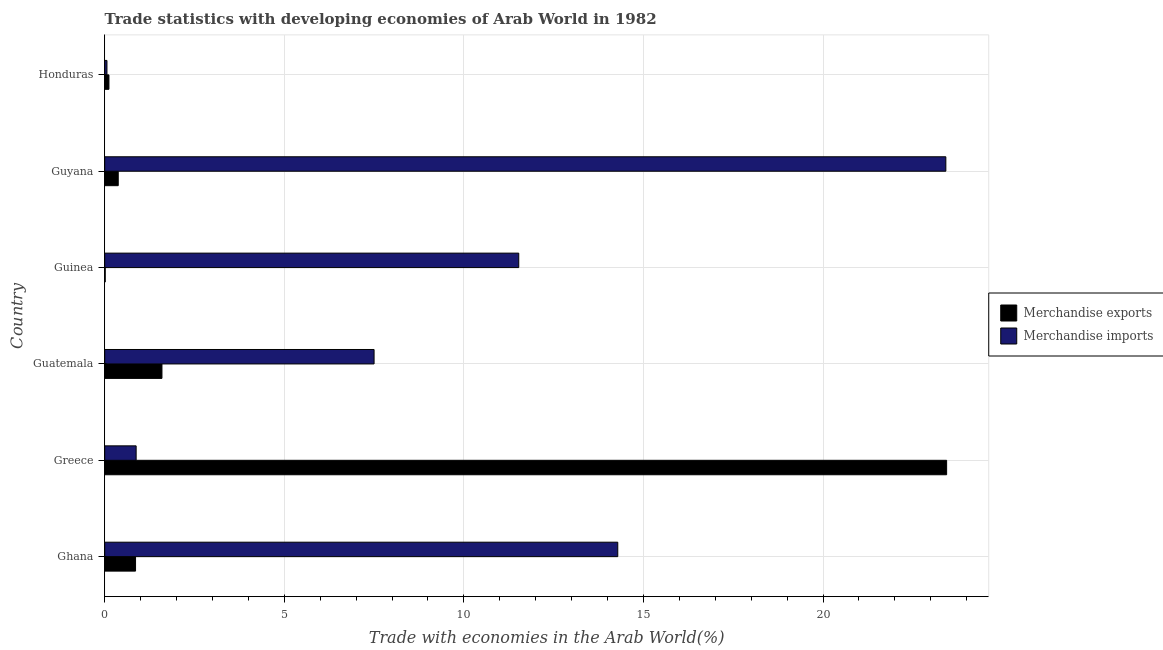How many different coloured bars are there?
Provide a short and direct response. 2. How many bars are there on the 4th tick from the top?
Keep it short and to the point. 2. How many bars are there on the 5th tick from the bottom?
Your answer should be compact. 2. What is the label of the 4th group of bars from the top?
Your response must be concise. Guatemala. In how many cases, is the number of bars for a given country not equal to the number of legend labels?
Your answer should be very brief. 0. What is the merchandise imports in Guatemala?
Offer a very short reply. 7.5. Across all countries, what is the maximum merchandise imports?
Provide a succinct answer. 23.42. Across all countries, what is the minimum merchandise exports?
Your response must be concise. 0.01. In which country was the merchandise imports maximum?
Offer a terse response. Guyana. In which country was the merchandise exports minimum?
Offer a terse response. Guinea. What is the total merchandise exports in the graph?
Your response must be concise. 26.4. What is the difference between the merchandise exports in Guatemala and that in Honduras?
Give a very brief answer. 1.48. What is the difference between the merchandise exports in Guinea and the merchandise imports in Greece?
Give a very brief answer. -0.86. What is the difference between the merchandise exports and merchandise imports in Guyana?
Offer a terse response. -23.04. In how many countries, is the merchandise exports greater than 14 %?
Keep it short and to the point. 1. What is the ratio of the merchandise exports in Guinea to that in Honduras?
Keep it short and to the point. 0.12. Is the merchandise imports in Guyana less than that in Honduras?
Ensure brevity in your answer.  No. Is the difference between the merchandise exports in Guatemala and Guyana greater than the difference between the merchandise imports in Guatemala and Guyana?
Offer a very short reply. Yes. What is the difference between the highest and the second highest merchandise exports?
Offer a very short reply. 21.85. What is the difference between the highest and the lowest merchandise exports?
Ensure brevity in your answer.  23.43. Is the sum of the merchandise exports in Guatemala and Guyana greater than the maximum merchandise imports across all countries?
Provide a short and direct response. No. What does the 1st bar from the bottom in Honduras represents?
Provide a succinct answer. Merchandise exports. How many countries are there in the graph?
Your answer should be compact. 6. What is the difference between two consecutive major ticks on the X-axis?
Provide a succinct answer. 5. Does the graph contain grids?
Provide a short and direct response. Yes. Where does the legend appear in the graph?
Ensure brevity in your answer.  Center right. How are the legend labels stacked?
Your response must be concise. Vertical. What is the title of the graph?
Ensure brevity in your answer.  Trade statistics with developing economies of Arab World in 1982. What is the label or title of the X-axis?
Your answer should be compact. Trade with economies in the Arab World(%). What is the label or title of the Y-axis?
Ensure brevity in your answer.  Country. What is the Trade with economies in the Arab World(%) of Merchandise exports in Ghana?
Offer a terse response. 0.86. What is the Trade with economies in the Arab World(%) in Merchandise imports in Ghana?
Ensure brevity in your answer.  14.29. What is the Trade with economies in the Arab World(%) in Merchandise exports in Greece?
Offer a terse response. 23.44. What is the Trade with economies in the Arab World(%) in Merchandise imports in Greece?
Your answer should be compact. 0.88. What is the Trade with economies in the Arab World(%) of Merchandise exports in Guatemala?
Make the answer very short. 1.59. What is the Trade with economies in the Arab World(%) of Merchandise imports in Guatemala?
Give a very brief answer. 7.5. What is the Trade with economies in the Arab World(%) of Merchandise exports in Guinea?
Provide a succinct answer. 0.01. What is the Trade with economies in the Arab World(%) of Merchandise imports in Guinea?
Give a very brief answer. 11.53. What is the Trade with economies in the Arab World(%) in Merchandise exports in Guyana?
Make the answer very short. 0.38. What is the Trade with economies in the Arab World(%) of Merchandise imports in Guyana?
Provide a short and direct response. 23.42. What is the Trade with economies in the Arab World(%) in Merchandise exports in Honduras?
Provide a short and direct response. 0.12. What is the Trade with economies in the Arab World(%) of Merchandise imports in Honduras?
Offer a very short reply. 0.06. Across all countries, what is the maximum Trade with economies in the Arab World(%) of Merchandise exports?
Give a very brief answer. 23.44. Across all countries, what is the maximum Trade with economies in the Arab World(%) of Merchandise imports?
Keep it short and to the point. 23.42. Across all countries, what is the minimum Trade with economies in the Arab World(%) in Merchandise exports?
Make the answer very short. 0.01. Across all countries, what is the minimum Trade with economies in the Arab World(%) of Merchandise imports?
Provide a short and direct response. 0.06. What is the total Trade with economies in the Arab World(%) of Merchandise exports in the graph?
Your answer should be compact. 26.4. What is the total Trade with economies in the Arab World(%) of Merchandise imports in the graph?
Give a very brief answer. 57.67. What is the difference between the Trade with economies in the Arab World(%) in Merchandise exports in Ghana and that in Greece?
Provide a succinct answer. -22.58. What is the difference between the Trade with economies in the Arab World(%) in Merchandise imports in Ghana and that in Greece?
Offer a terse response. 13.41. What is the difference between the Trade with economies in the Arab World(%) of Merchandise exports in Ghana and that in Guatemala?
Your answer should be very brief. -0.74. What is the difference between the Trade with economies in the Arab World(%) of Merchandise imports in Ghana and that in Guatemala?
Keep it short and to the point. 6.79. What is the difference between the Trade with economies in the Arab World(%) of Merchandise exports in Ghana and that in Guinea?
Make the answer very short. 0.84. What is the difference between the Trade with economies in the Arab World(%) in Merchandise imports in Ghana and that in Guinea?
Offer a terse response. 2.76. What is the difference between the Trade with economies in the Arab World(%) of Merchandise exports in Ghana and that in Guyana?
Give a very brief answer. 0.48. What is the difference between the Trade with economies in the Arab World(%) in Merchandise imports in Ghana and that in Guyana?
Give a very brief answer. -9.14. What is the difference between the Trade with economies in the Arab World(%) of Merchandise exports in Ghana and that in Honduras?
Ensure brevity in your answer.  0.74. What is the difference between the Trade with economies in the Arab World(%) in Merchandise imports in Ghana and that in Honduras?
Provide a succinct answer. 14.22. What is the difference between the Trade with economies in the Arab World(%) in Merchandise exports in Greece and that in Guatemala?
Your answer should be very brief. 21.85. What is the difference between the Trade with economies in the Arab World(%) of Merchandise imports in Greece and that in Guatemala?
Ensure brevity in your answer.  -6.62. What is the difference between the Trade with economies in the Arab World(%) of Merchandise exports in Greece and that in Guinea?
Make the answer very short. 23.43. What is the difference between the Trade with economies in the Arab World(%) of Merchandise imports in Greece and that in Guinea?
Your answer should be very brief. -10.65. What is the difference between the Trade with economies in the Arab World(%) in Merchandise exports in Greece and that in Guyana?
Your answer should be very brief. 23.07. What is the difference between the Trade with economies in the Arab World(%) of Merchandise imports in Greece and that in Guyana?
Provide a short and direct response. -22.55. What is the difference between the Trade with economies in the Arab World(%) in Merchandise exports in Greece and that in Honduras?
Your answer should be very brief. 23.33. What is the difference between the Trade with economies in the Arab World(%) in Merchandise imports in Greece and that in Honduras?
Give a very brief answer. 0.81. What is the difference between the Trade with economies in the Arab World(%) of Merchandise exports in Guatemala and that in Guinea?
Offer a very short reply. 1.58. What is the difference between the Trade with economies in the Arab World(%) in Merchandise imports in Guatemala and that in Guinea?
Offer a terse response. -4.03. What is the difference between the Trade with economies in the Arab World(%) of Merchandise exports in Guatemala and that in Guyana?
Give a very brief answer. 1.22. What is the difference between the Trade with economies in the Arab World(%) of Merchandise imports in Guatemala and that in Guyana?
Offer a very short reply. -15.92. What is the difference between the Trade with economies in the Arab World(%) of Merchandise exports in Guatemala and that in Honduras?
Keep it short and to the point. 1.48. What is the difference between the Trade with economies in the Arab World(%) in Merchandise imports in Guatemala and that in Honduras?
Keep it short and to the point. 7.44. What is the difference between the Trade with economies in the Arab World(%) of Merchandise exports in Guinea and that in Guyana?
Ensure brevity in your answer.  -0.36. What is the difference between the Trade with economies in the Arab World(%) in Merchandise imports in Guinea and that in Guyana?
Offer a terse response. -11.89. What is the difference between the Trade with economies in the Arab World(%) of Merchandise exports in Guinea and that in Honduras?
Provide a short and direct response. -0.1. What is the difference between the Trade with economies in the Arab World(%) of Merchandise imports in Guinea and that in Honduras?
Provide a succinct answer. 11.47. What is the difference between the Trade with economies in the Arab World(%) of Merchandise exports in Guyana and that in Honduras?
Offer a very short reply. 0.26. What is the difference between the Trade with economies in the Arab World(%) in Merchandise imports in Guyana and that in Honduras?
Provide a succinct answer. 23.36. What is the difference between the Trade with economies in the Arab World(%) in Merchandise exports in Ghana and the Trade with economies in the Arab World(%) in Merchandise imports in Greece?
Make the answer very short. -0.02. What is the difference between the Trade with economies in the Arab World(%) of Merchandise exports in Ghana and the Trade with economies in the Arab World(%) of Merchandise imports in Guatemala?
Offer a very short reply. -6.64. What is the difference between the Trade with economies in the Arab World(%) of Merchandise exports in Ghana and the Trade with economies in the Arab World(%) of Merchandise imports in Guinea?
Ensure brevity in your answer.  -10.67. What is the difference between the Trade with economies in the Arab World(%) in Merchandise exports in Ghana and the Trade with economies in the Arab World(%) in Merchandise imports in Guyana?
Your answer should be compact. -22.56. What is the difference between the Trade with economies in the Arab World(%) in Merchandise exports in Ghana and the Trade with economies in the Arab World(%) in Merchandise imports in Honduras?
Ensure brevity in your answer.  0.8. What is the difference between the Trade with economies in the Arab World(%) in Merchandise exports in Greece and the Trade with economies in the Arab World(%) in Merchandise imports in Guatemala?
Provide a short and direct response. 15.94. What is the difference between the Trade with economies in the Arab World(%) of Merchandise exports in Greece and the Trade with economies in the Arab World(%) of Merchandise imports in Guinea?
Give a very brief answer. 11.91. What is the difference between the Trade with economies in the Arab World(%) of Merchandise exports in Greece and the Trade with economies in the Arab World(%) of Merchandise imports in Guyana?
Give a very brief answer. 0.02. What is the difference between the Trade with economies in the Arab World(%) of Merchandise exports in Greece and the Trade with economies in the Arab World(%) of Merchandise imports in Honduras?
Provide a succinct answer. 23.38. What is the difference between the Trade with economies in the Arab World(%) of Merchandise exports in Guatemala and the Trade with economies in the Arab World(%) of Merchandise imports in Guinea?
Give a very brief answer. -9.94. What is the difference between the Trade with economies in the Arab World(%) of Merchandise exports in Guatemala and the Trade with economies in the Arab World(%) of Merchandise imports in Guyana?
Make the answer very short. -21.83. What is the difference between the Trade with economies in the Arab World(%) in Merchandise exports in Guatemala and the Trade with economies in the Arab World(%) in Merchandise imports in Honduras?
Offer a very short reply. 1.53. What is the difference between the Trade with economies in the Arab World(%) of Merchandise exports in Guinea and the Trade with economies in the Arab World(%) of Merchandise imports in Guyana?
Your answer should be compact. -23.41. What is the difference between the Trade with economies in the Arab World(%) in Merchandise exports in Guinea and the Trade with economies in the Arab World(%) in Merchandise imports in Honduras?
Your answer should be very brief. -0.05. What is the difference between the Trade with economies in the Arab World(%) in Merchandise exports in Guyana and the Trade with economies in the Arab World(%) in Merchandise imports in Honduras?
Keep it short and to the point. 0.31. What is the average Trade with economies in the Arab World(%) in Merchandise exports per country?
Offer a terse response. 4.4. What is the average Trade with economies in the Arab World(%) in Merchandise imports per country?
Provide a short and direct response. 9.61. What is the difference between the Trade with economies in the Arab World(%) in Merchandise exports and Trade with economies in the Arab World(%) in Merchandise imports in Ghana?
Ensure brevity in your answer.  -13.43. What is the difference between the Trade with economies in the Arab World(%) in Merchandise exports and Trade with economies in the Arab World(%) in Merchandise imports in Greece?
Your answer should be compact. 22.57. What is the difference between the Trade with economies in the Arab World(%) of Merchandise exports and Trade with economies in the Arab World(%) of Merchandise imports in Guatemala?
Give a very brief answer. -5.91. What is the difference between the Trade with economies in the Arab World(%) in Merchandise exports and Trade with economies in the Arab World(%) in Merchandise imports in Guinea?
Offer a terse response. -11.51. What is the difference between the Trade with economies in the Arab World(%) in Merchandise exports and Trade with economies in the Arab World(%) in Merchandise imports in Guyana?
Keep it short and to the point. -23.04. What is the difference between the Trade with economies in the Arab World(%) in Merchandise exports and Trade with economies in the Arab World(%) in Merchandise imports in Honduras?
Your answer should be compact. 0.06. What is the ratio of the Trade with economies in the Arab World(%) of Merchandise exports in Ghana to that in Greece?
Offer a very short reply. 0.04. What is the ratio of the Trade with economies in the Arab World(%) of Merchandise imports in Ghana to that in Greece?
Your answer should be compact. 16.32. What is the ratio of the Trade with economies in the Arab World(%) in Merchandise exports in Ghana to that in Guatemala?
Offer a terse response. 0.54. What is the ratio of the Trade with economies in the Arab World(%) of Merchandise imports in Ghana to that in Guatemala?
Provide a short and direct response. 1.9. What is the ratio of the Trade with economies in the Arab World(%) of Merchandise exports in Ghana to that in Guinea?
Offer a very short reply. 61.55. What is the ratio of the Trade with economies in the Arab World(%) of Merchandise imports in Ghana to that in Guinea?
Offer a terse response. 1.24. What is the ratio of the Trade with economies in the Arab World(%) in Merchandise exports in Ghana to that in Guyana?
Keep it short and to the point. 2.28. What is the ratio of the Trade with economies in the Arab World(%) in Merchandise imports in Ghana to that in Guyana?
Give a very brief answer. 0.61. What is the ratio of the Trade with economies in the Arab World(%) of Merchandise exports in Ghana to that in Honduras?
Offer a terse response. 7.3. What is the ratio of the Trade with economies in the Arab World(%) of Merchandise imports in Ghana to that in Honduras?
Provide a succinct answer. 228.81. What is the ratio of the Trade with economies in the Arab World(%) in Merchandise exports in Greece to that in Guatemala?
Keep it short and to the point. 14.71. What is the ratio of the Trade with economies in the Arab World(%) of Merchandise imports in Greece to that in Guatemala?
Offer a very short reply. 0.12. What is the ratio of the Trade with economies in the Arab World(%) of Merchandise exports in Greece to that in Guinea?
Your answer should be compact. 1681.19. What is the ratio of the Trade with economies in the Arab World(%) of Merchandise imports in Greece to that in Guinea?
Provide a short and direct response. 0.08. What is the ratio of the Trade with economies in the Arab World(%) in Merchandise exports in Greece to that in Guyana?
Provide a succinct answer. 62.26. What is the ratio of the Trade with economies in the Arab World(%) in Merchandise imports in Greece to that in Guyana?
Give a very brief answer. 0.04. What is the ratio of the Trade with economies in the Arab World(%) of Merchandise exports in Greece to that in Honduras?
Offer a very short reply. 199.41. What is the ratio of the Trade with economies in the Arab World(%) in Merchandise imports in Greece to that in Honduras?
Your answer should be very brief. 14.02. What is the ratio of the Trade with economies in the Arab World(%) of Merchandise exports in Guatemala to that in Guinea?
Your answer should be very brief. 114.28. What is the ratio of the Trade with economies in the Arab World(%) in Merchandise imports in Guatemala to that in Guinea?
Provide a short and direct response. 0.65. What is the ratio of the Trade with economies in the Arab World(%) of Merchandise exports in Guatemala to that in Guyana?
Provide a succinct answer. 4.23. What is the ratio of the Trade with economies in the Arab World(%) in Merchandise imports in Guatemala to that in Guyana?
Offer a very short reply. 0.32. What is the ratio of the Trade with economies in the Arab World(%) in Merchandise exports in Guatemala to that in Honduras?
Your response must be concise. 13.56. What is the ratio of the Trade with economies in the Arab World(%) of Merchandise imports in Guatemala to that in Honduras?
Provide a succinct answer. 120.13. What is the ratio of the Trade with economies in the Arab World(%) in Merchandise exports in Guinea to that in Guyana?
Offer a very short reply. 0.04. What is the ratio of the Trade with economies in the Arab World(%) in Merchandise imports in Guinea to that in Guyana?
Keep it short and to the point. 0.49. What is the ratio of the Trade with economies in the Arab World(%) in Merchandise exports in Guinea to that in Honduras?
Keep it short and to the point. 0.12. What is the ratio of the Trade with economies in the Arab World(%) of Merchandise imports in Guinea to that in Honduras?
Ensure brevity in your answer.  184.65. What is the ratio of the Trade with economies in the Arab World(%) of Merchandise exports in Guyana to that in Honduras?
Offer a very short reply. 3.2. What is the ratio of the Trade with economies in the Arab World(%) in Merchandise imports in Guyana to that in Honduras?
Make the answer very short. 375.13. What is the difference between the highest and the second highest Trade with economies in the Arab World(%) of Merchandise exports?
Provide a short and direct response. 21.85. What is the difference between the highest and the second highest Trade with economies in the Arab World(%) in Merchandise imports?
Provide a short and direct response. 9.14. What is the difference between the highest and the lowest Trade with economies in the Arab World(%) in Merchandise exports?
Your answer should be compact. 23.43. What is the difference between the highest and the lowest Trade with economies in the Arab World(%) in Merchandise imports?
Give a very brief answer. 23.36. 